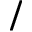Convert formula to latex. <formula><loc_0><loc_0><loc_500><loc_500>/</formula> 